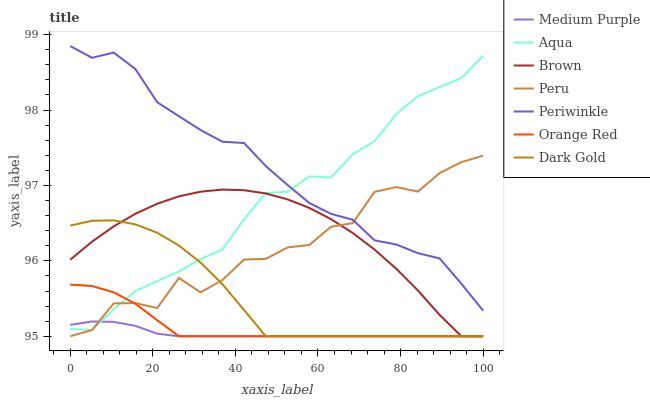Does Dark Gold have the minimum area under the curve?
Answer yes or no. No. Does Dark Gold have the maximum area under the curve?
Answer yes or no. No. Is Dark Gold the smoothest?
Answer yes or no. No. Is Dark Gold the roughest?
Answer yes or no. No. Does Aqua have the lowest value?
Answer yes or no. No. Does Dark Gold have the highest value?
Answer yes or no. No. Is Orange Red less than Periwinkle?
Answer yes or no. Yes. Is Periwinkle greater than Brown?
Answer yes or no. Yes. Does Orange Red intersect Periwinkle?
Answer yes or no. No. 